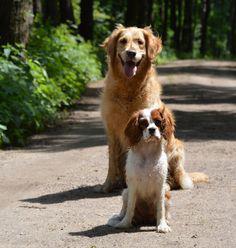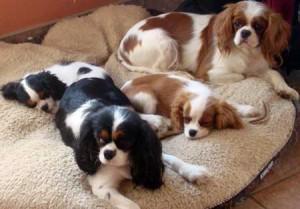The first image is the image on the left, the second image is the image on the right. Given the left and right images, does the statement "The right image contains at least two dogs." hold true? Answer yes or no. Yes. The first image is the image on the left, the second image is the image on the right. Given the left and right images, does the statement "The left image features one golden retriever and one brown and white colored cocker spaniel" hold true? Answer yes or no. Yes. 